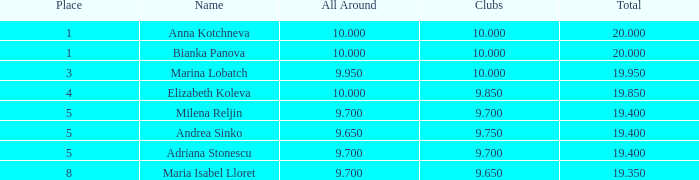7? None. 